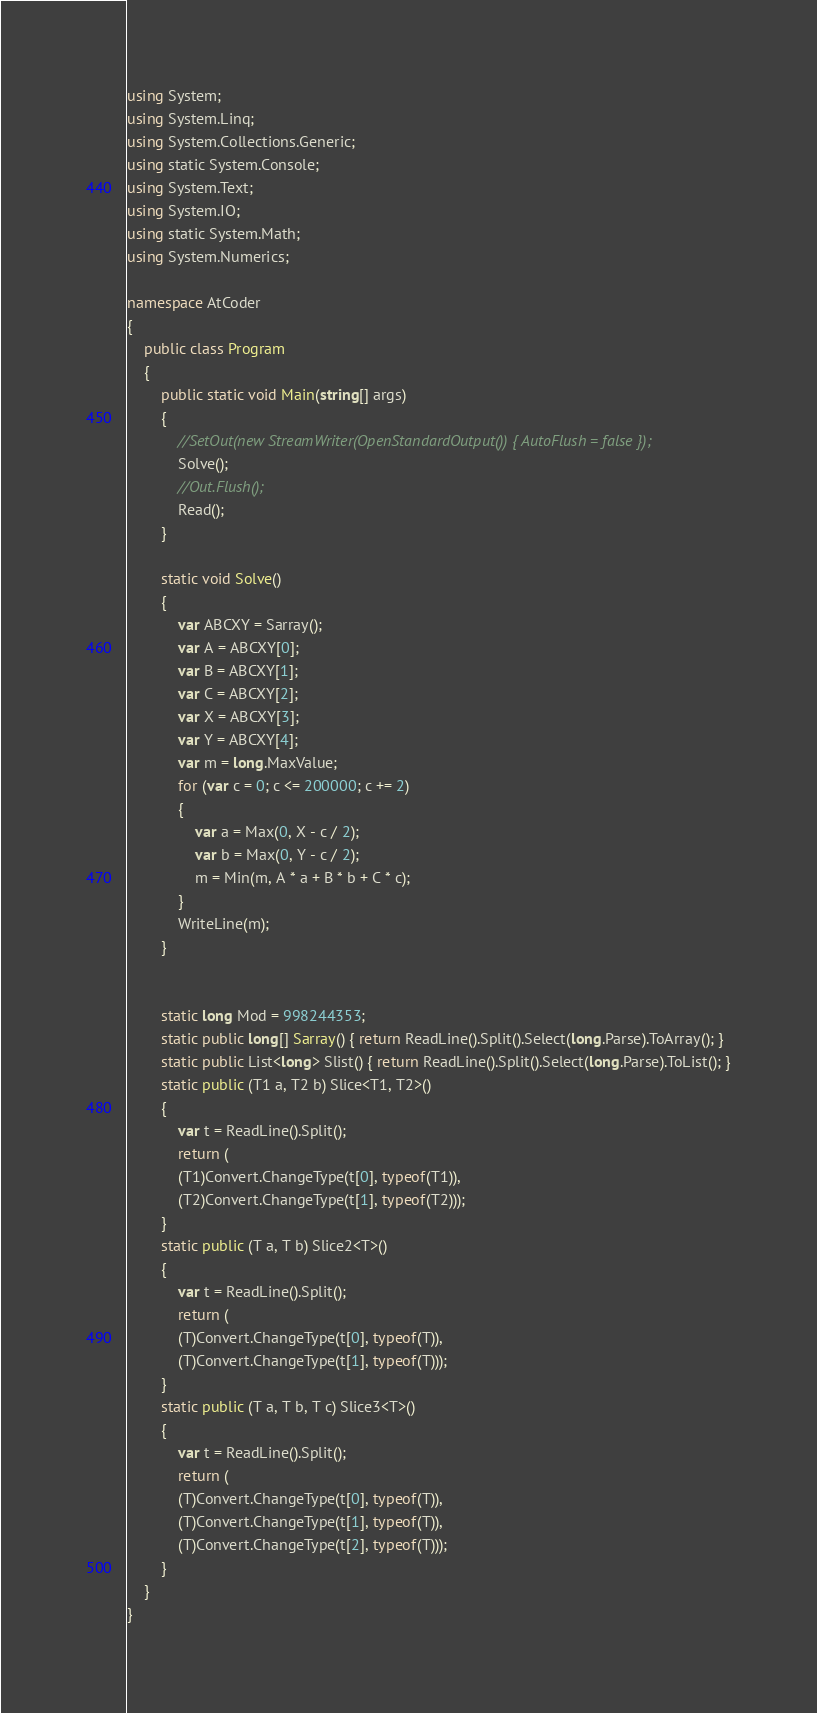<code> <loc_0><loc_0><loc_500><loc_500><_C#_>using System;
using System.Linq;
using System.Collections.Generic;
using static System.Console;
using System.Text;
using System.IO;
using static System.Math;
using System.Numerics;

namespace AtCoder
{
    public class Program
    {
        public static void Main(string[] args)
        {
            //SetOut(new StreamWriter(OpenStandardOutput()) { AutoFlush = false });
            Solve();
            //Out.Flush();
            Read();
        }

        static void Solve()
        {
            var ABCXY = Sarray();
            var A = ABCXY[0];
            var B = ABCXY[1];
            var C = ABCXY[2];
            var X = ABCXY[3];
            var Y = ABCXY[4];
            var m = long.MaxValue;
            for (var c = 0; c <= 200000; c += 2)
            {
                var a = Max(0, X - c / 2);
                var b = Max(0, Y - c / 2);
                m = Min(m, A * a + B * b + C * c);
            }
            WriteLine(m);
        }


        static long Mod = 998244353;
        static public long[] Sarray() { return ReadLine().Split().Select(long.Parse).ToArray(); }
        static public List<long> Slist() { return ReadLine().Split().Select(long.Parse).ToList(); }
        static public (T1 a, T2 b) Slice<T1, T2>()
        {
            var t = ReadLine().Split();
            return (
            (T1)Convert.ChangeType(t[0], typeof(T1)),
            (T2)Convert.ChangeType(t[1], typeof(T2)));
        }
        static public (T a, T b) Slice2<T>()
        {
            var t = ReadLine().Split();
            return (
            (T)Convert.ChangeType(t[0], typeof(T)),
            (T)Convert.ChangeType(t[1], typeof(T)));
        }
        static public (T a, T b, T c) Slice3<T>()
        {
            var t = ReadLine().Split();
            return (
            (T)Convert.ChangeType(t[0], typeof(T)),
            (T)Convert.ChangeType(t[1], typeof(T)),
            (T)Convert.ChangeType(t[2], typeof(T)));
        }
    }
}</code> 